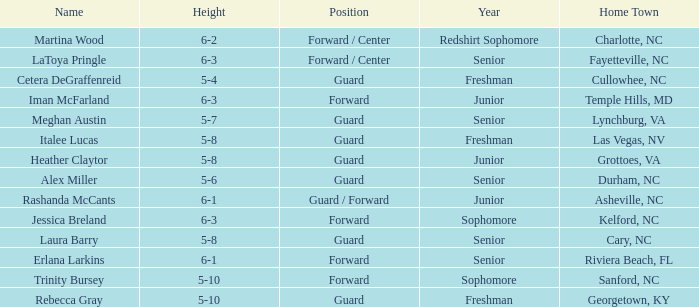In what year of school is the player from Fayetteville, NC? Senior. 